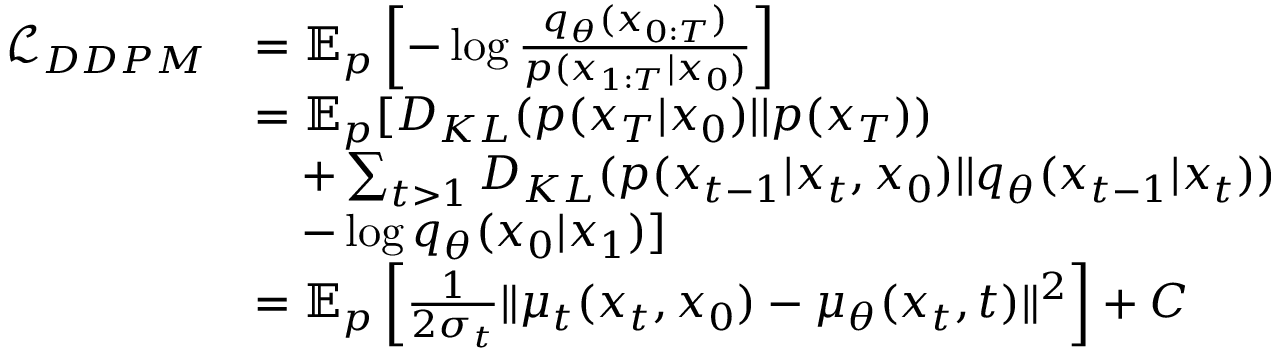<formula> <loc_0><loc_0><loc_500><loc_500>\begin{array} { r l } { \mathcal { L } _ { D D P M } } & { = \mathbb { E } _ { p } \left [ - \log \frac { q _ { \theta } ( x _ { 0 \colon T } ) } { p ( x _ { 1 \colon T } | x _ { 0 } ) } \right ] } \\ & { = \mathbb { E } _ { p } [ D _ { K L } ( p ( x _ { T } | x _ { 0 } ) | | p ( x _ { T } ) ) } \\ & { \quad + \sum _ { t > 1 } D _ { K L } ( p ( x _ { t - 1 } | x _ { t } , x _ { 0 } ) | | q _ { \theta } ( x _ { t - 1 } | x _ { t } ) ) } \\ & { \quad - \log q _ { \theta } ( x _ { 0 } | x _ { 1 } ) ] } \\ & { = \mathbb { E } _ { p } \left [ \frac { 1 } { 2 \sigma _ { t } } \| \mu _ { t } ( x _ { t } , x _ { 0 } ) - \mu _ { \theta } ( x _ { t } , t ) \| ^ { 2 } \right ] + C } \end{array}</formula> 